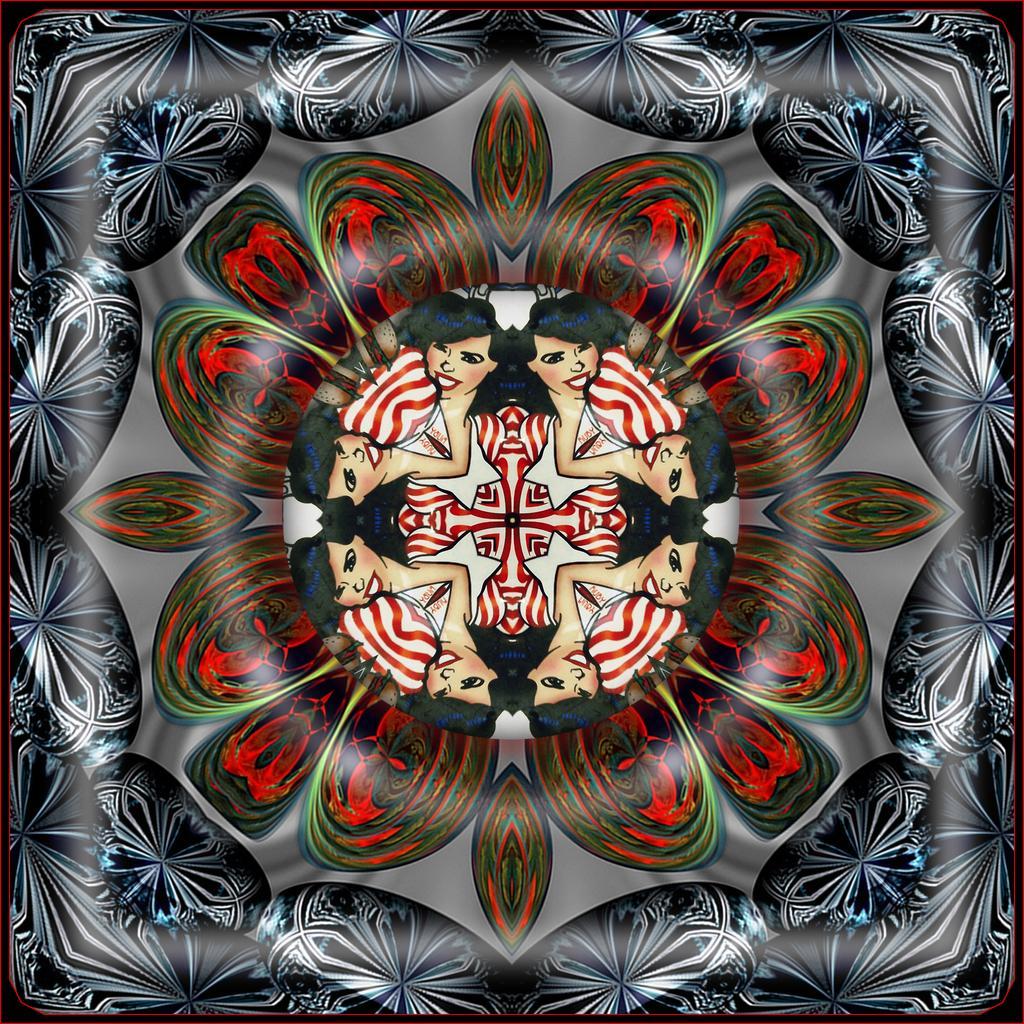In one or two sentences, can you explain what this image depicts? This is a painting. In this painting, we can see there are women, a flower and other designs. And the background of this painting is gray in color. 